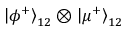Convert formula to latex. <formula><loc_0><loc_0><loc_500><loc_500>\left | \phi ^ { + } \right \rangle _ { 1 2 } \otimes \left | \mu ^ { + } \right \rangle _ { 1 2 }</formula> 